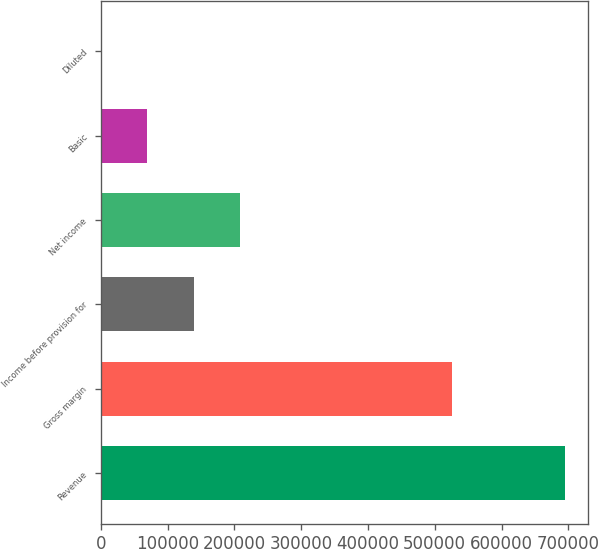<chart> <loc_0><loc_0><loc_500><loc_500><bar_chart><fcel>Revenue<fcel>Gross margin<fcel>Income before provision for<fcel>Net income<fcel>Basic<fcel>Diluted<nl><fcel>695381<fcel>525835<fcel>139077<fcel>208615<fcel>69538.8<fcel>0.75<nl></chart> 